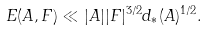<formula> <loc_0><loc_0><loc_500><loc_500>E ( A , F ) \ll | A | | F | ^ { 3 / 2 } d _ { * } ( A ) ^ { 1 / 2 } .</formula> 